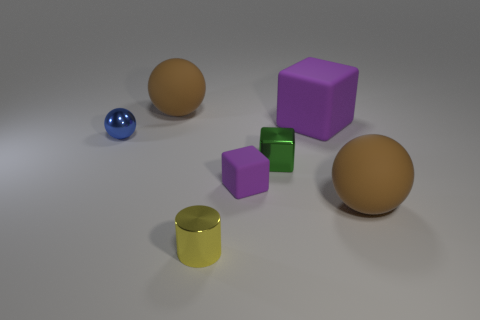Are there the same number of tiny purple matte things to the left of the tiny green shiny object and tiny yellow metallic objects that are to the right of the tiny shiny ball?
Keep it short and to the point. Yes. How many purple objects are either small cubes or tiny cylinders?
Your answer should be very brief. 1. What number of green metallic objects are the same size as the blue metal object?
Your answer should be compact. 1. There is a thing that is both behind the green shiny thing and to the right of the tiny metallic cube; what is its color?
Give a very brief answer. Purple. Are there more purple rubber things that are in front of the blue metallic thing than gray cylinders?
Ensure brevity in your answer.  Yes. Is there a small purple object?
Your response must be concise. Yes. Does the cylinder have the same color as the big rubber cube?
Give a very brief answer. No. How many tiny things are either purple cylinders or blocks?
Give a very brief answer. 2. Is there any other thing that is the same color as the tiny metallic sphere?
Provide a short and direct response. No. What is the shape of the tiny object that is the same material as the big purple block?
Provide a succinct answer. Cube. 